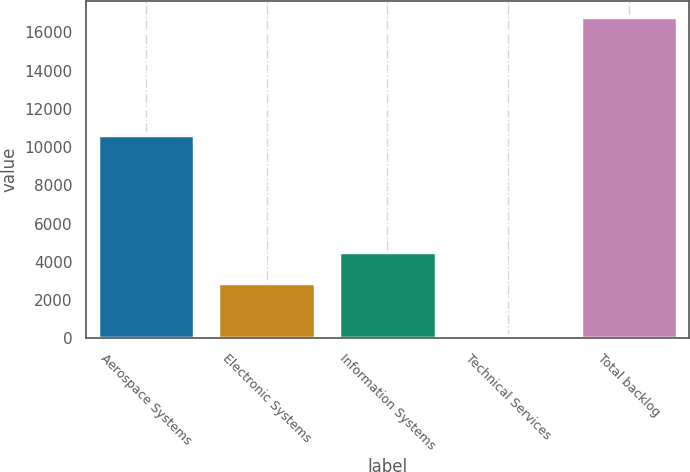Convert chart. <chart><loc_0><loc_0><loc_500><loc_500><bar_chart><fcel>Aerospace Systems<fcel>Electronic Systems<fcel>Information Systems<fcel>Technical Services<fcel>Total backlog<nl><fcel>10625<fcel>2870<fcel>4534.7<fcel>179<fcel>16826<nl></chart> 